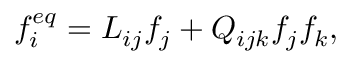Convert formula to latex. <formula><loc_0><loc_0><loc_500><loc_500>f _ { i } ^ { e q } = L _ { i j } f _ { j } + Q _ { i j k } f _ { j } f _ { k } ,</formula> 